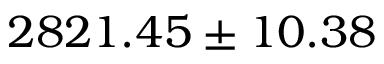<formula> <loc_0><loc_0><loc_500><loc_500>2 8 2 1 . 4 5 \pm 1 0 . 3 8</formula> 